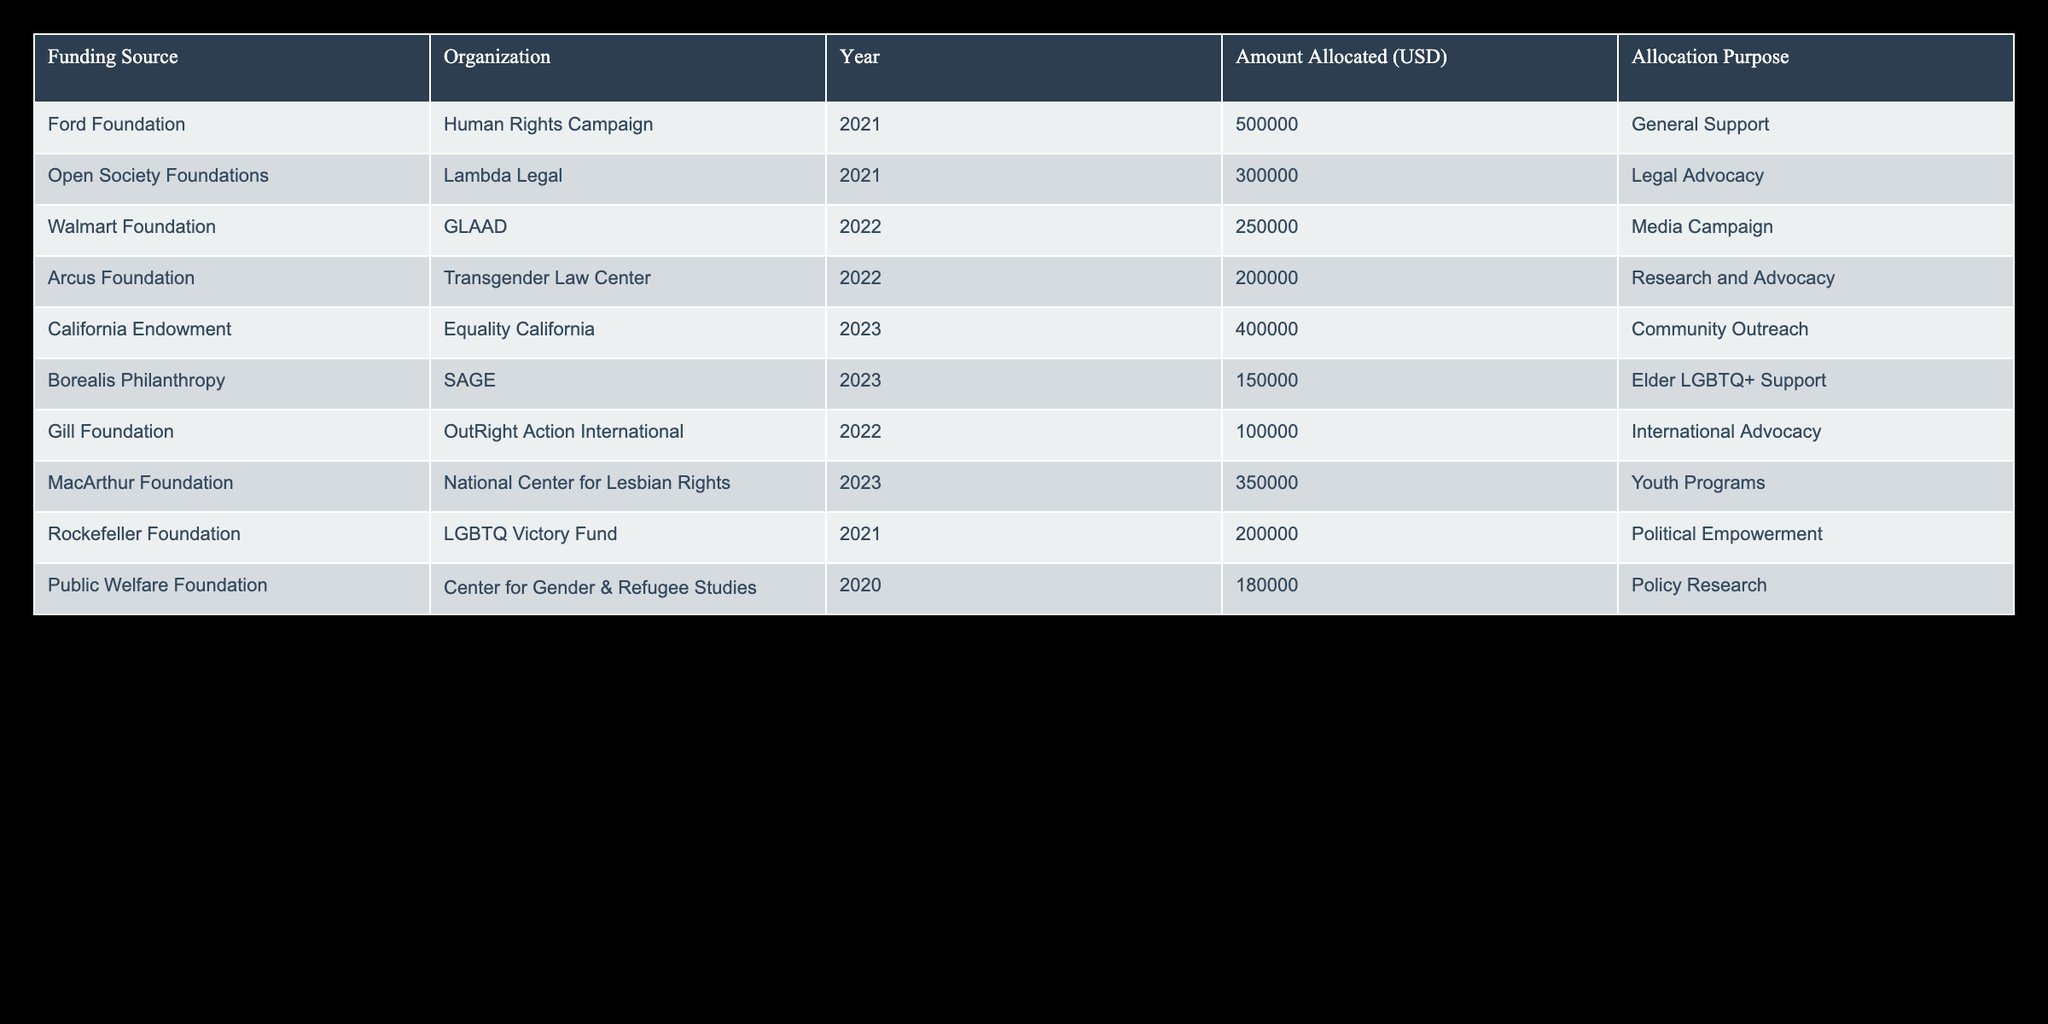What is the total amount allocated to the Human Rights Campaign? The table lists a single allocation of 500,000 USD to the Human Rights Campaign from the Ford Foundation in 2021. Since there are no other allocations for this organization, the total is simply the value given.
Answer: 500000 USD Which organization received the most funding in 2023? The table shows two allocations in 2023: 400,000 USD for Equality California and 350,000 USD for the National Center for Lesbian Rights. The highest amount is for Equality California.
Answer: Equality California How many organizations received funding from the Arcus Foundation? According to the table, only one organization, the Transgender Law Center, received funding from the Arcus Foundation, which is listed in 2022.
Answer: 1 What was the total funding amount allocated in 2022? The table lists two organizations funded in 2022: GLAAD with 250,000 USD and OutRight Action International with 100,000 USD. Adding these amounts gives 250,000 + 100,000 = 350,000 USD, which is the total allocation for that year.
Answer: 350000 USD Was any funding allocated for elder LGBTQ+ support? The table explicitly states that SAGE received 150,000 USD in 2023 for elder LGBTQ+ support, confirming that there was funding allocated for this purpose.
Answer: Yes Which funding source allocated money for media campaigns? The table indicates that the Walmart Foundation allocated 250,000 USD to GLAAD in 2022 specifically for a media campaign. Therefore, this is the funding source related to media campaigns.
Answer: Walmart Foundation What is the total amount allocated for community outreach? Only one allocation for community outreach appears in the table, which is for 400,000 USD to Equality California in 2023. There are no other entries for community outreach in the data, so the total is this single amount.
Answer: 400000 USD In which year did the Center for Gender & Refugee Studies receive funding? The table indicates that the Center for Gender & Refugee Studies received funding in 2020, as per the entry listed in that year.
Answer: 2020 How many different funding sources are listed in the table? The table features a total of 8 unique funding sources listed in the "Funding Source" column. Each source is counted once regardless of how many organizations they funded.
Answer: 8 